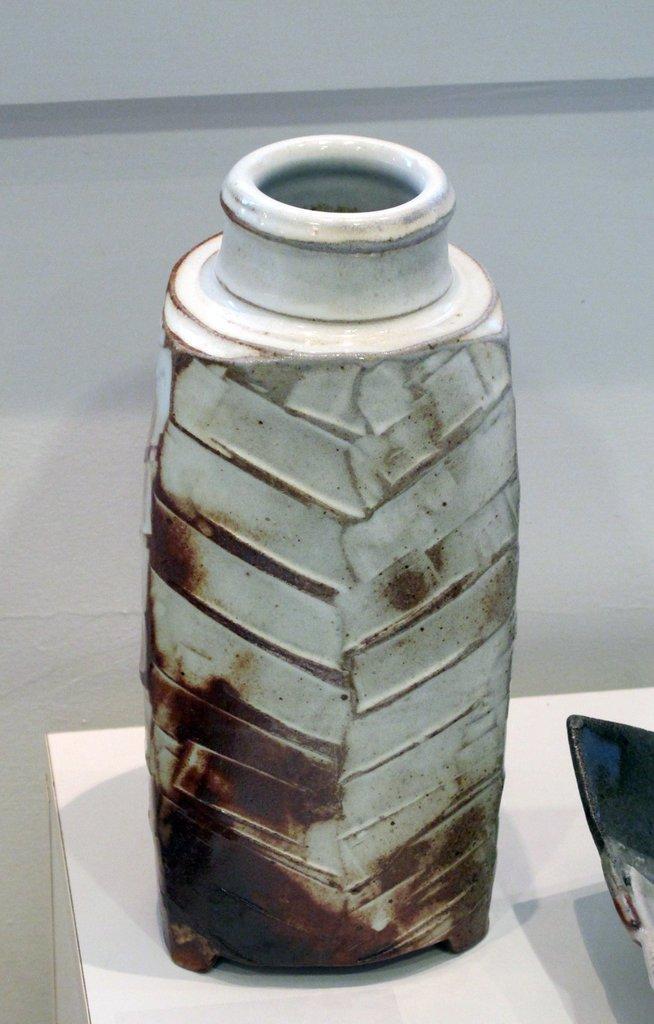Describe this image in one or two sentences. In the image there is a ceramic bottle kept on a table. 